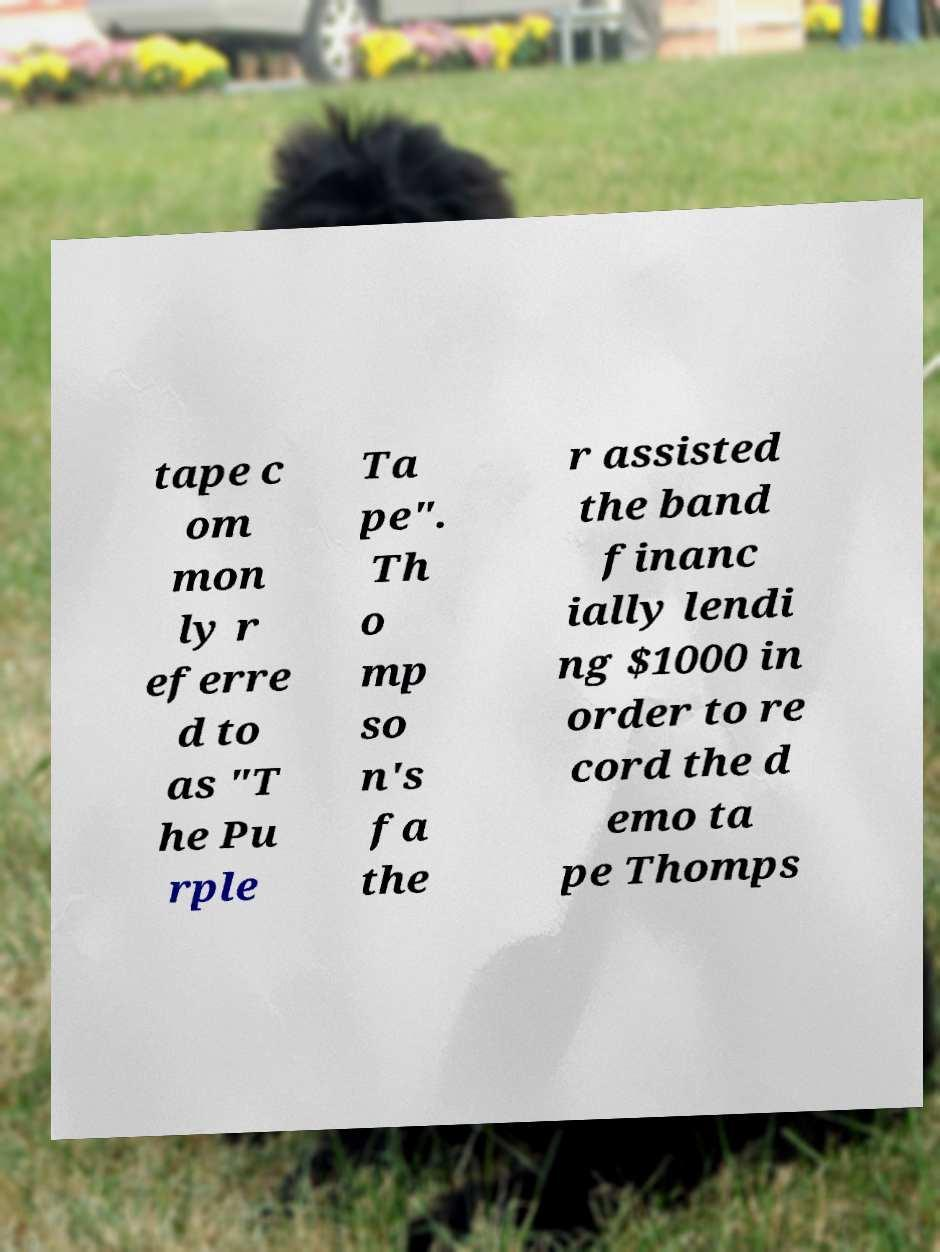Can you read and provide the text displayed in the image?This photo seems to have some interesting text. Can you extract and type it out for me? tape c om mon ly r eferre d to as "T he Pu rple Ta pe". Th o mp so n's fa the r assisted the band financ ially lendi ng $1000 in order to re cord the d emo ta pe Thomps 